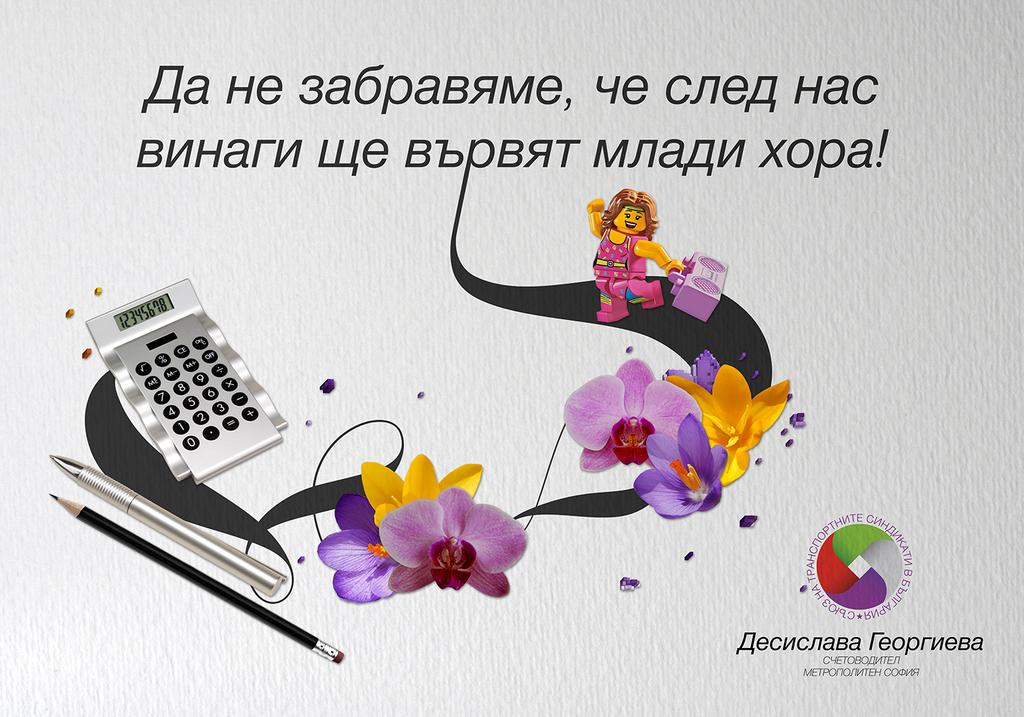What type of visual is the image? The image is a poster. What can be found on the poster besides images? There is text and a logo on the poster. What objects are depicted on the poster? A pen, a pencil, a flower, and a calculator are depicted on the poster. What is the person holding on the poster? The person is holding a music player on the poster. How many clocks are depicted on the poster? There are no clocks depicted on the poster. What type of prison is shown in the image? There is no prison present in the image; it is a poster with various objects and a person holding a music player. 